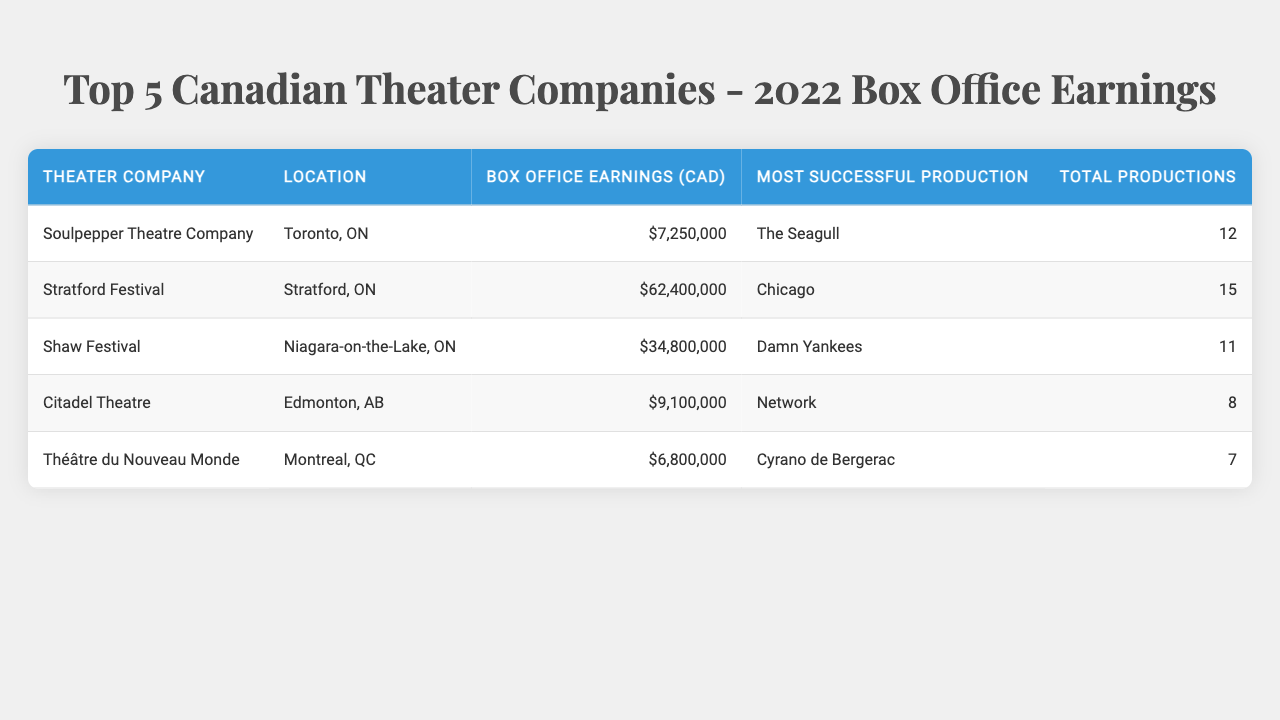What theater company had the highest box office earnings in 2022? The table shows that the Stratford Festival had the highest box office earnings at $62,400,000.
Answer: Stratford Festival How much did the Citadel Theatre earn in 2022? According to the table, the Citadel Theatre earned $9,100,000 in box office earnings.
Answer: $9,100,000 Which production was the most successful for Soulpepper Theatre Company? The table indicates that the most successful production for Soulpepper Theatre Company was "The Seagull."
Answer: The Seagull How many productions did the Shaw Festival have in 2022? The table states that the Shaw Festival had a total of 11 productions in 2022.
Answer: 11 What is the total box office earnings of the top 5 theater companies? To find the total, we add up all the box office earnings: 7,250,000 + 62,400,000 + 34,800,000 + 9,100,000 + 6,800,000 = 120,350,000.
Answer: $120,350,000 Is the average box office earning of the listed theater companies more than $20 million? Calculate the average: Total earnings = 120,350,000; Number of companies = 5; Average = 120,350,000 / 5 = 24,070,000, which is greater than $20 million.
Answer: Yes Which company had the lowest box office earnings, and what was the amount? The table shows that the Théâtre du Nouveau Monde had the lowest box office earnings of $6,800,000.
Answer: Théâtre du Nouveau Monde, $6,800,000 How much more did the Shaw Festival earn compared to the Théâtre du Nouveau Monde? Calculating the difference: Shaw Festival earnings = 34,800,000; Théâtre du Nouveau Monde earnings = 6,800,000; Difference = 34,800,000 - 6,800,000 = 28,000,000.
Answer: $28,000,000 What is the total number of productions for the top 5 companies? The total number of productions is calculated by adding the productions: 12 + 15 + 11 + 8 + 7 = 53.
Answer: 53 Which theater company is located in Montreal? The table specifies that the Théâtre du Nouveau Monde is located in Montreal, QC.
Answer: Théâtre du Nouveau Monde 